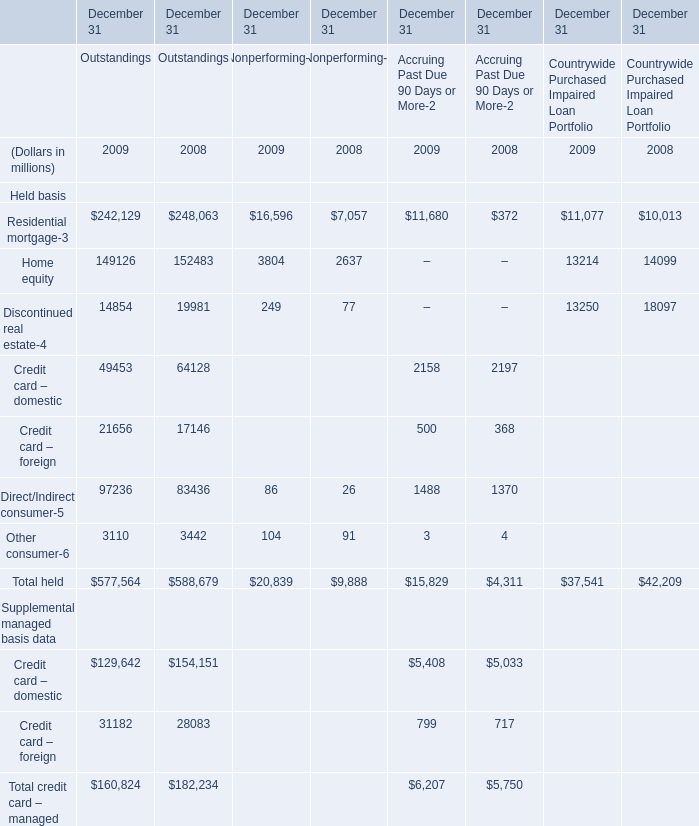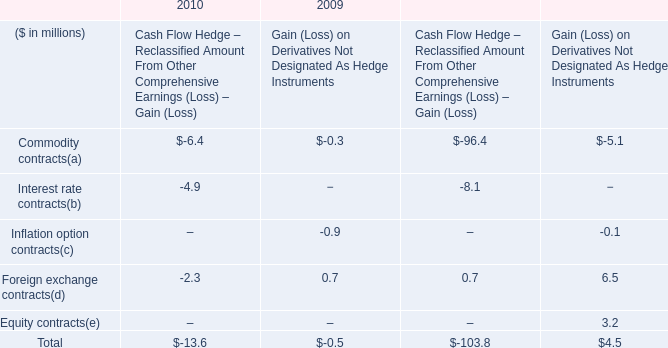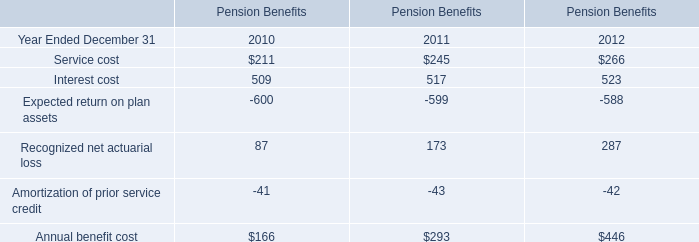In what year is Home equity of Outstandings greater than 150000? 
Answer: 2008. 